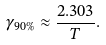Convert formula to latex. <formula><loc_0><loc_0><loc_500><loc_500>\gamma _ { 9 0 \% } \approx \frac { 2 . 3 0 3 } { T } .</formula> 